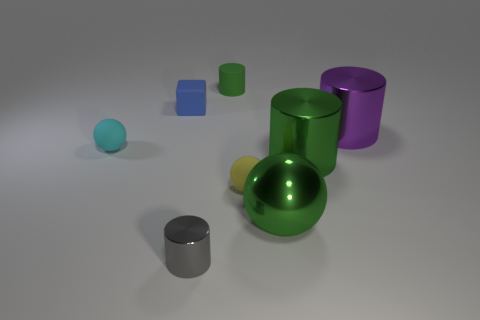Which object in this image appears to be the largest? The object that appears to be the largest is the green cylinder. Its size dominates the scene and it stands out prominently compared to the other shapes. 